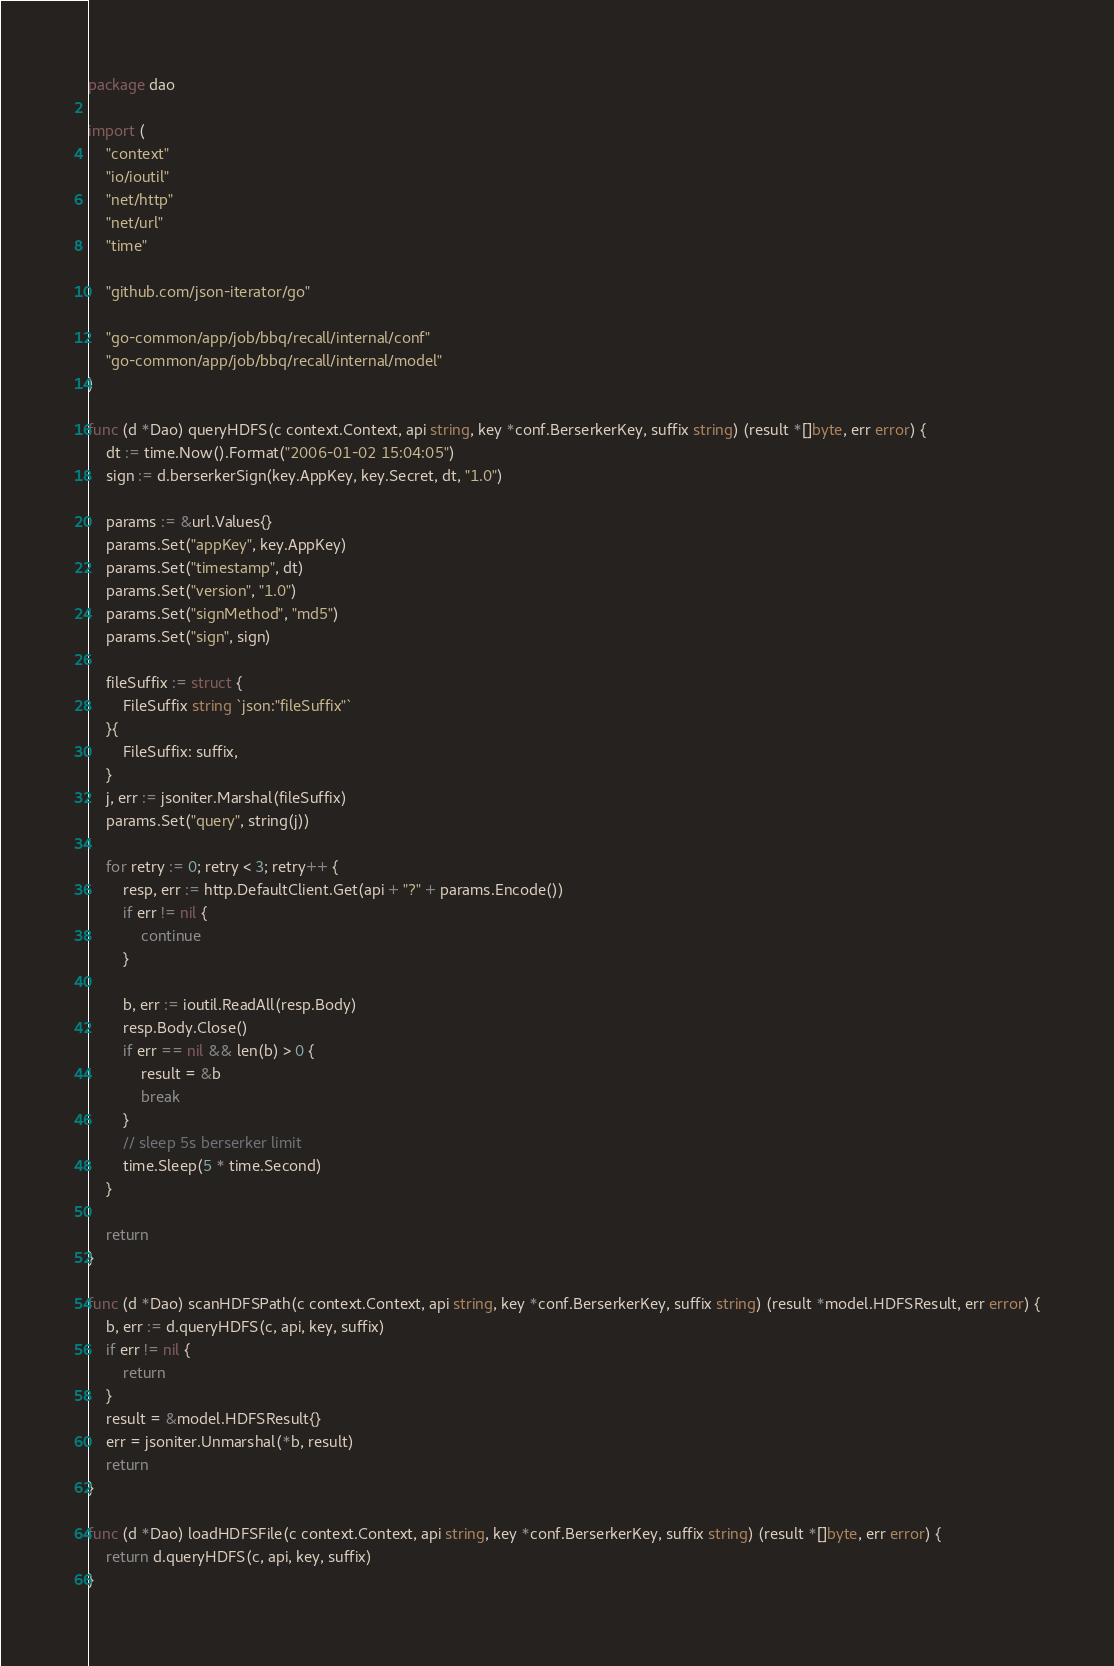<code> <loc_0><loc_0><loc_500><loc_500><_Go_>package dao

import (
	"context"
	"io/ioutil"
	"net/http"
	"net/url"
	"time"

	"github.com/json-iterator/go"

	"go-common/app/job/bbq/recall/internal/conf"
	"go-common/app/job/bbq/recall/internal/model"
)

func (d *Dao) queryHDFS(c context.Context, api string, key *conf.BerserkerKey, suffix string) (result *[]byte, err error) {
	dt := time.Now().Format("2006-01-02 15:04:05")
	sign := d.berserkerSign(key.AppKey, key.Secret, dt, "1.0")

	params := &url.Values{}
	params.Set("appKey", key.AppKey)
	params.Set("timestamp", dt)
	params.Set("version", "1.0")
	params.Set("signMethod", "md5")
	params.Set("sign", sign)

	fileSuffix := struct {
		FileSuffix string `json:"fileSuffix"`
	}{
		FileSuffix: suffix,
	}
	j, err := jsoniter.Marshal(fileSuffix)
	params.Set("query", string(j))

	for retry := 0; retry < 3; retry++ {
		resp, err := http.DefaultClient.Get(api + "?" + params.Encode())
		if err != nil {
			continue
		}

		b, err := ioutil.ReadAll(resp.Body)
		resp.Body.Close()
		if err == nil && len(b) > 0 {
			result = &b
			break
		}
		// sleep 5s berserker limit
		time.Sleep(5 * time.Second)
	}

	return
}

func (d *Dao) scanHDFSPath(c context.Context, api string, key *conf.BerserkerKey, suffix string) (result *model.HDFSResult, err error) {
	b, err := d.queryHDFS(c, api, key, suffix)
	if err != nil {
		return
	}
	result = &model.HDFSResult{}
	err = jsoniter.Unmarshal(*b, result)
	return
}

func (d *Dao) loadHDFSFile(c context.Context, api string, key *conf.BerserkerKey, suffix string) (result *[]byte, err error) {
	return d.queryHDFS(c, api, key, suffix)
}
</code> 